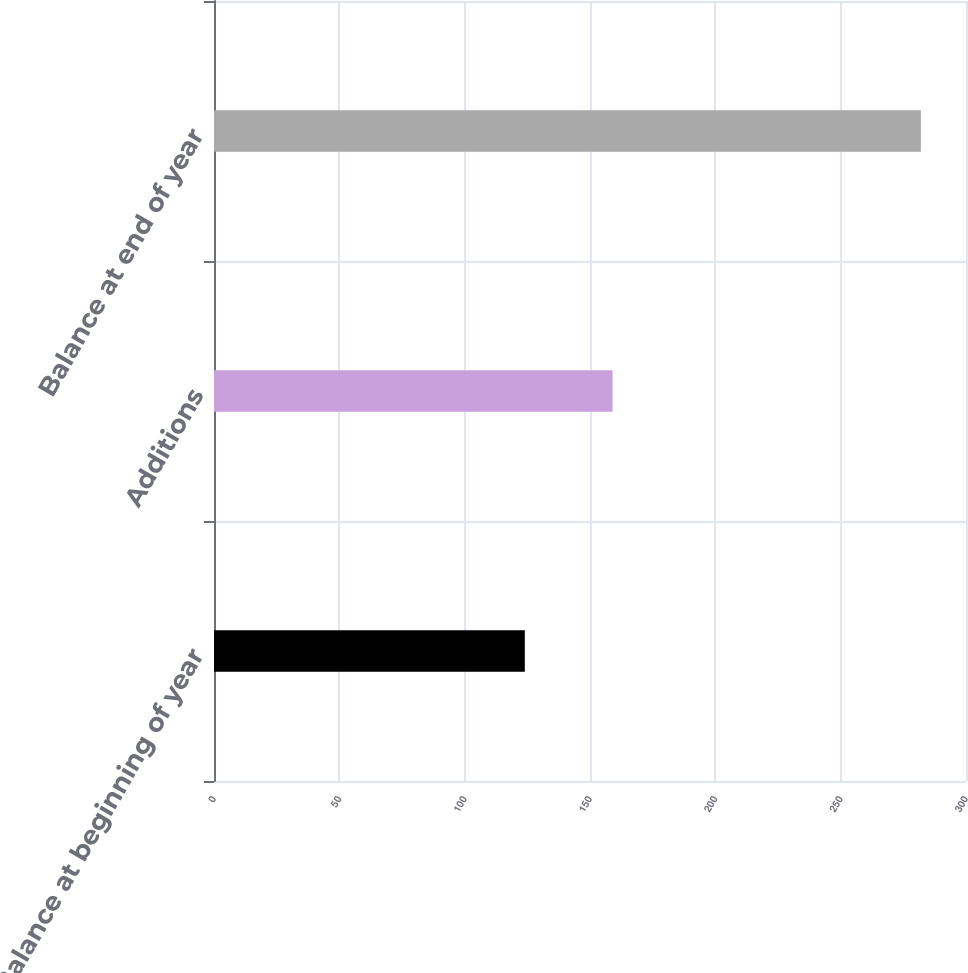Convert chart. <chart><loc_0><loc_0><loc_500><loc_500><bar_chart><fcel>Balance at beginning of year<fcel>Additions<fcel>Balance at end of year<nl><fcel>124<fcel>159<fcel>282<nl></chart> 